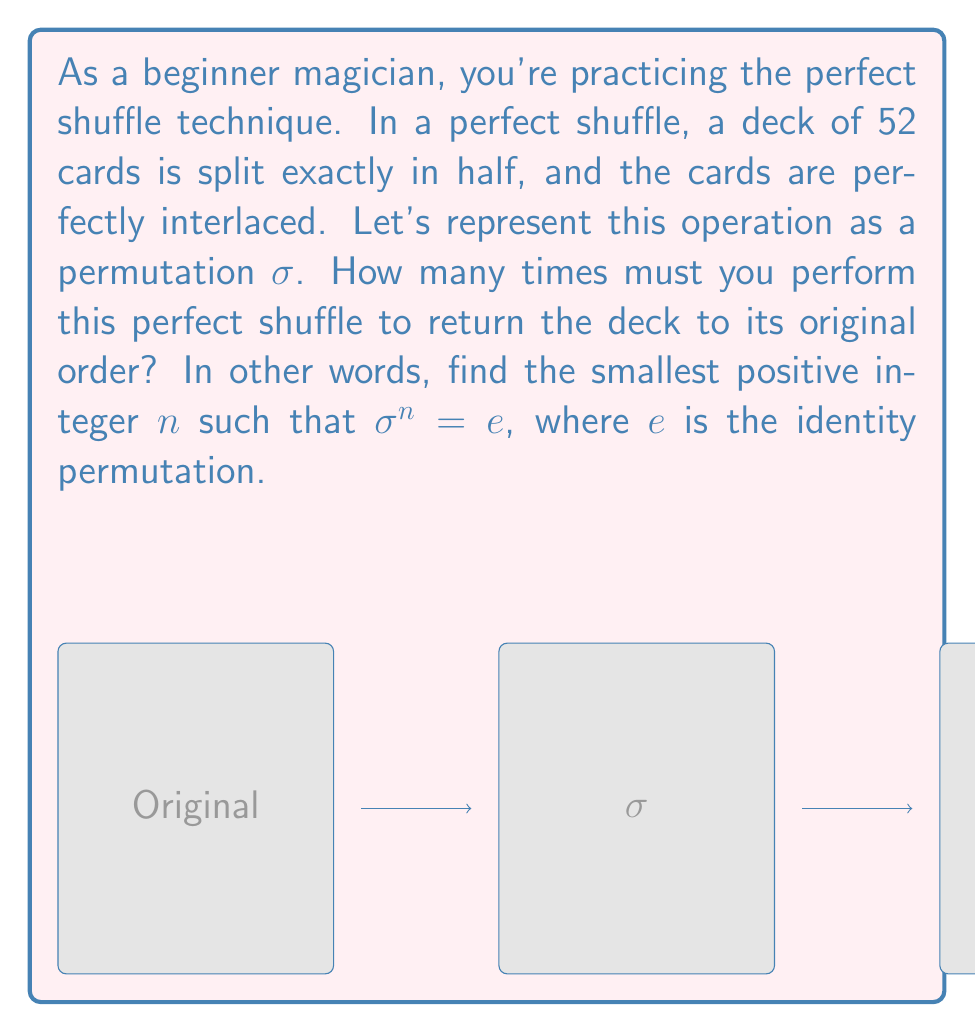What is the answer to this math problem? Let's approach this step-by-step using group theory:

1) First, we need to understand what the perfect shuffle does to the position of each card. Let's number the cards from 0 to 51.

2) After one perfect shuffle, the new position of a card originally at position $i$ is given by:
   $$\sigma(i) = (2i \bmod 51) \text{ if } i < 26$$
   $$\sigma(i) = (2i + 1 \bmod 53) - 1 \text{ if } i \geq 26$$

3) To find when the deck returns to its original order, we need to find the order of this permutation in the symmetric group $S_{52}$.

4) A key observation is that the order of a permutation is the least common multiple (LCM) of the lengths of its cycles.

5) Let's track the position of the top card (position 0):
   0 → 0 → 0
   The top card stays fixed.

6) Now let's track the second card (position 1):
   1 → 2 → 4 → 8 → 16 → 32 → 13 → 26 → 1
   This forms a cycle of length 8.

7) We can continue this process for all cards, but a shortcut is to realize that the cycle lengths will be the orders of 2 modulo the prime factors of 52 = 2^2 * 13.

8) The order of 2 modulo 13 is 12, and the order of 2 modulo 4 is 2.

9) Therefore, the order of the permutation is LCM(1, 8, 2, 12) = 24.

Thus, it takes 24 perfect shuffles to return the deck to its original order.
Answer: 24 